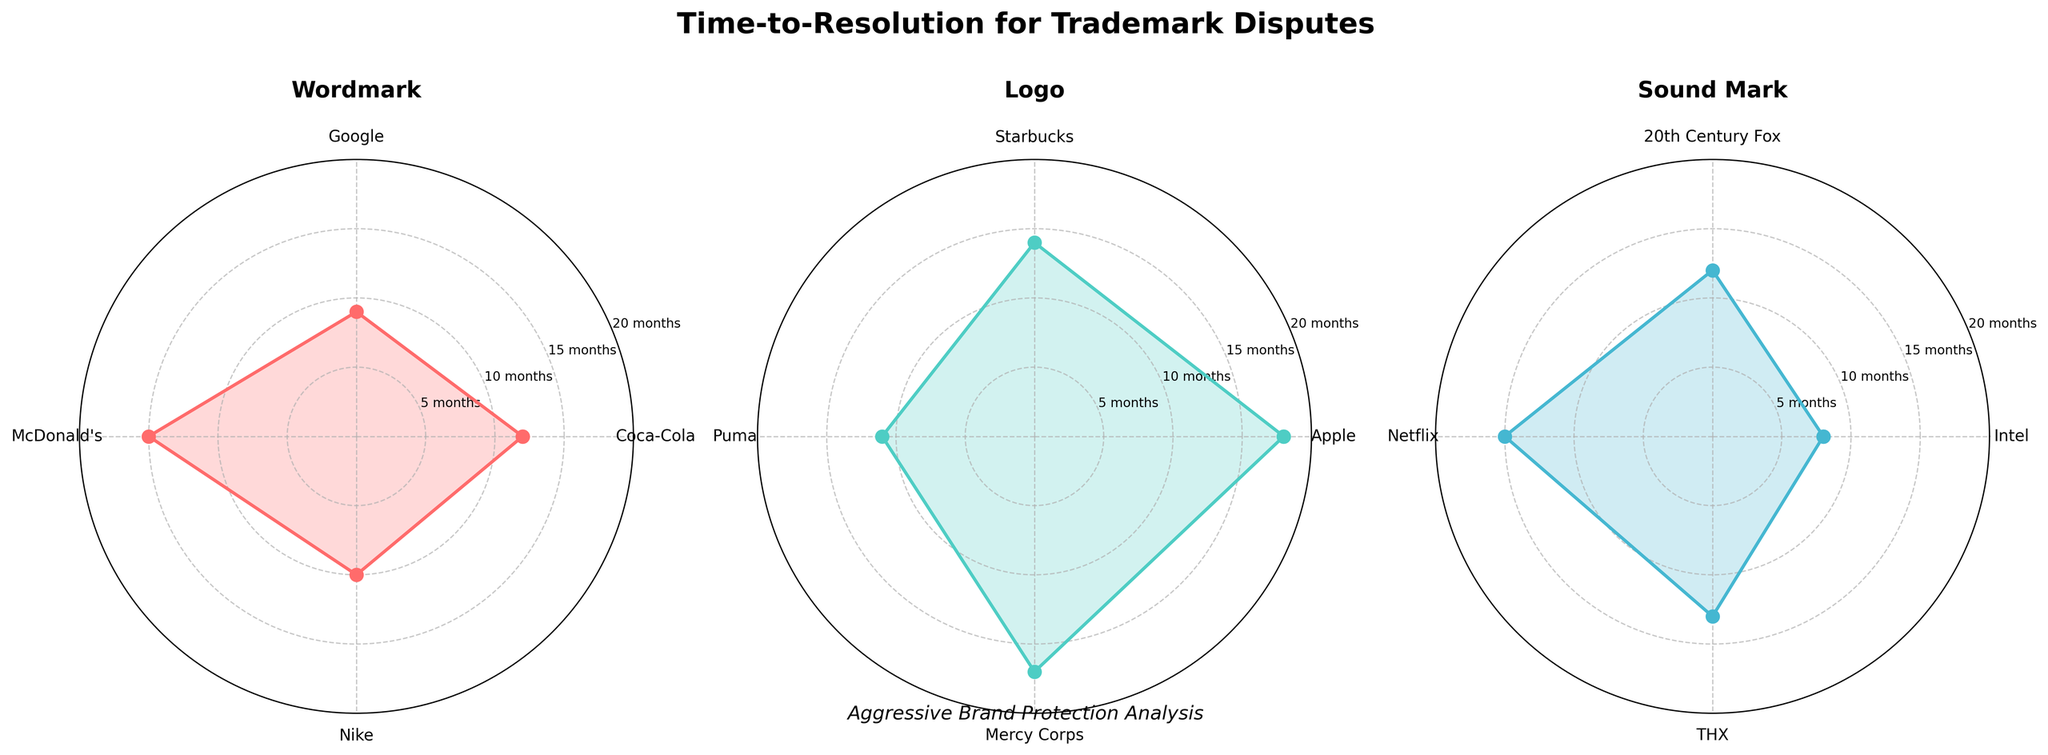What is the title of the figure? The title of the figure is typically displayed prominently at the top of the chart. In this case, it reads "Time-to-Resolution for Trademark Disputes".
Answer: Time-to-Resolution for Trademark Disputes What are the different categories of trademarks shown in the figure? The figure is divided into three subplots, each corresponding to a different nature of trademarks. The categories displayed as titles above each subplot are "Wordmark", "Logo", and "Sound Mark".
Answer: Wordmark, Logo, Sound Mark How many trademarks are there in the "Logo" category? The "Logo" subplot displays individual trademarks with labels around the polar chart. Counting these labels reveals four trademarks are shown for the "Logo" category: Apple, Starbucks, Puma, and Mercy Corps.
Answer: Four Which trademark in the "Sound Mark" category has the longest time to resolution, and what is that time? In the "Sound Mark" polar chart, you observe the values as points around the circle. "Netflix" has the highest point, which is 15 months.
Answer: Netflix, 15 months Compare the average time-to-resolution between "Wordmark" and "Sound Mark" categories. Which one is higher? Calculate the average time-to-resolution for each category. Wordmark: (12 + 9 + 15 + 10)/4 = 11.5 months. Sound Mark: (8 + 12 + 15 + 13)/4 = 12 months. The Sound Mark category has a slightly higher average compared to Wordmark.
Answer: Sound Mark What is the range of time-to-resolution in the "Wordmark" category? To find the range, identify the minimum and maximum values in the Wordmark category, which are 9 months (Google) and 15 months (McDonald's), respectively. The range is the difference between these two values: 15 - 9 = 6 months.
Answer: 6 months Which trademark in any category has the shortest time to resolution, and what is that time? Review the points in all three polar charts. The lowest point is observed in the "Sound Mark" subplot for the trademark "Intel", which is 8 months.
Answer: Intel, 8 months Between "Starbucks" and "Puma" logos, which has a shorter time-to-resolution? Look at the points for Starbucks and Puma in the "Logo" polar chart. Starbucks is at 14 months, and Puma is at 11 months. Therefore, Puma has a shorter time-to-resolution than Starbucks.
Answer: Puma Is there any category where all trademarks have a time-to-resolution of 15 months or less? Scan through each subplot and the points displayed. In the "Sound Mark" category, all marks (Intel, 20th Century Fox, Netflix, THX) have resolution times of 15 months or less, which is not true for Wordmark or Logo.
Answer: Sound Mark What's the highest time-to-resolution observed in any category, and which trademark corresponds to it? Check the maximum values in all subplots. The highest observed time-to-resolution is 18 months for the Apple logo in the Logo category.
Answer: Apple, 18 months 